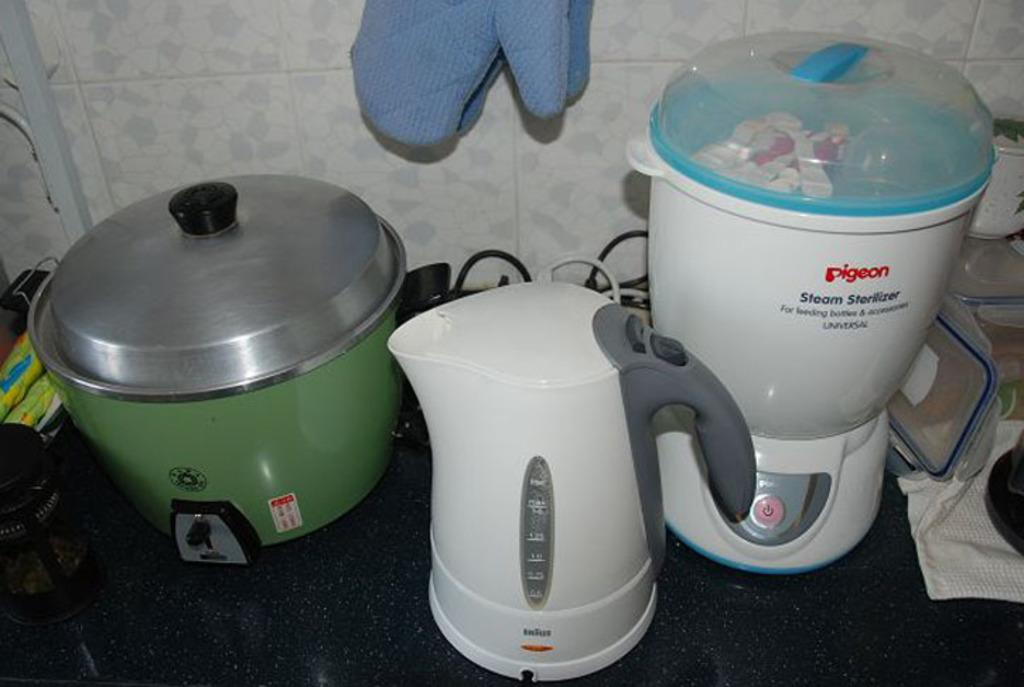<image>
Provide a brief description of the given image. A counter with various appliances including a Pigeon steam sterilizer. 